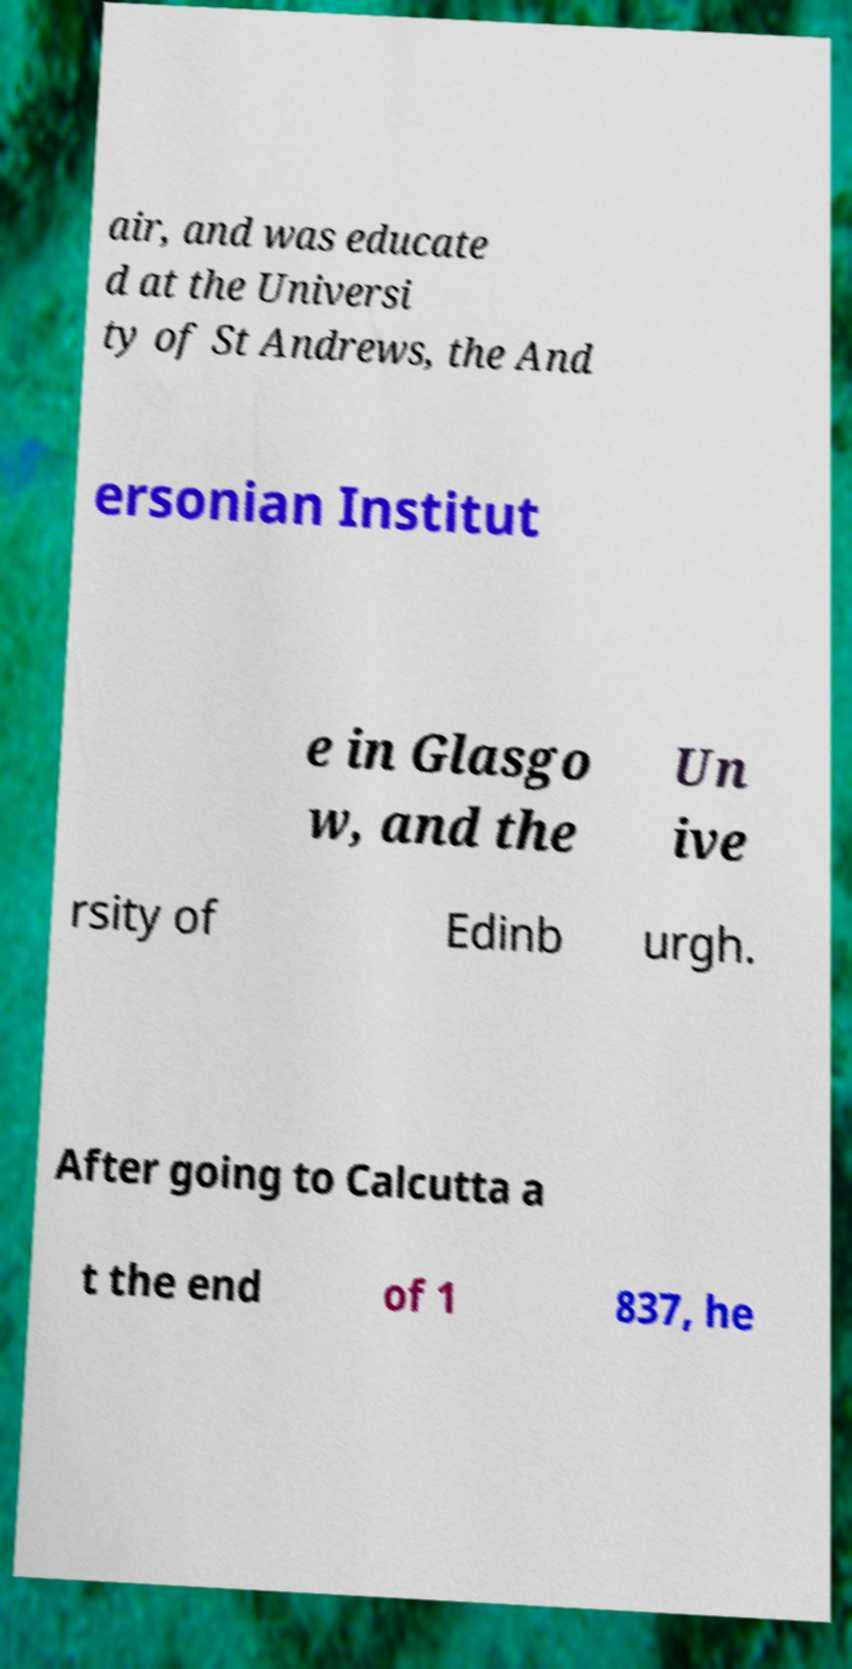Please identify and transcribe the text found in this image. air, and was educate d at the Universi ty of St Andrews, the And ersonian Institut e in Glasgo w, and the Un ive rsity of Edinb urgh. After going to Calcutta a t the end of 1 837, he 